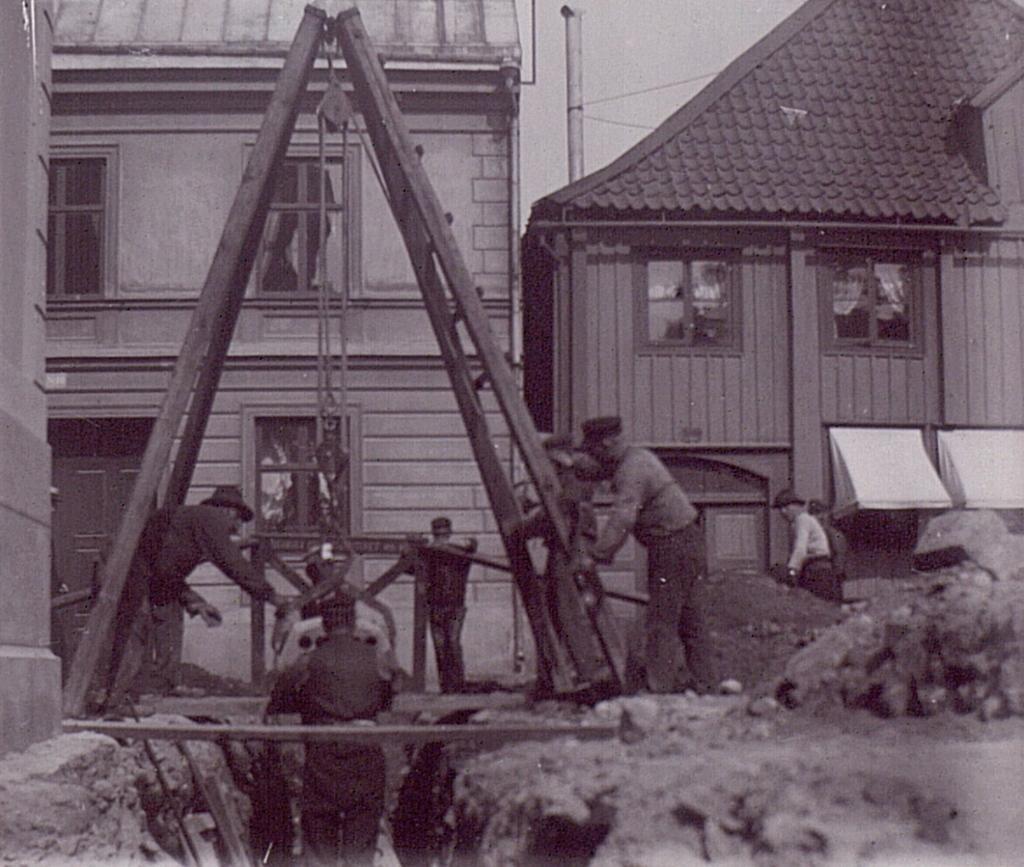How would you summarize this image in a sentence or two? This picture consists of houses and in front of houses I can see persons and I can see a stand in the middle , in the middle I can see pole and the sky. 